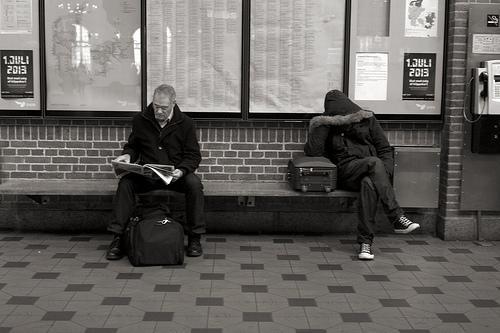How many people are there?
Give a very brief answer. 2. 